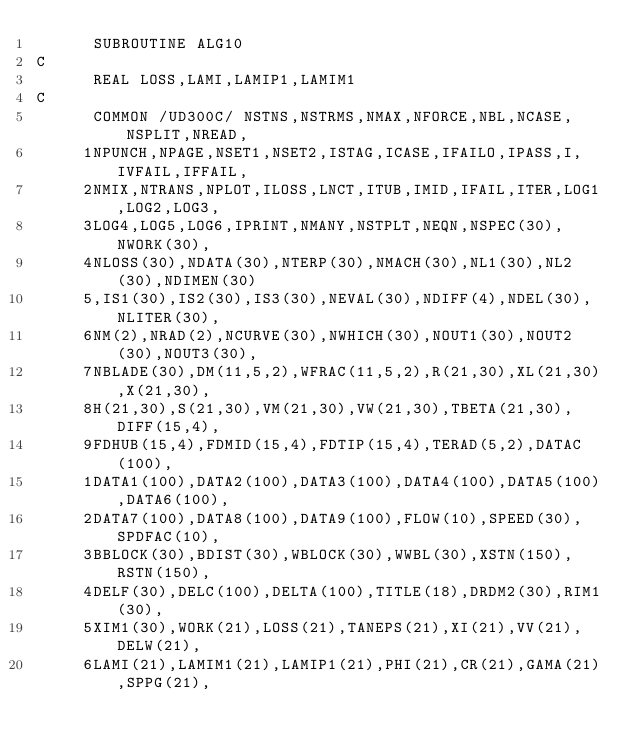<code> <loc_0><loc_0><loc_500><loc_500><_FORTRAN_>      SUBROUTINE ALG10
C
      REAL LOSS,LAMI,LAMIP1,LAMIM1
C
      COMMON /UD300C/ NSTNS,NSTRMS,NMAX,NFORCE,NBL,NCASE,NSPLIT,NREAD,
     1NPUNCH,NPAGE,NSET1,NSET2,ISTAG,ICASE,IFAILO,IPASS,I,IVFAIL,IFFAIL,
     2NMIX,NTRANS,NPLOT,ILOSS,LNCT,ITUB,IMID,IFAIL,ITER,LOG1,LOG2,LOG3,
     3LOG4,LOG5,LOG6,IPRINT,NMANY,NSTPLT,NEQN,NSPEC(30),NWORK(30),
     4NLOSS(30),NDATA(30),NTERP(30),NMACH(30),NL1(30),NL2(30),NDIMEN(30)
     5,IS1(30),IS2(30),IS3(30),NEVAL(30),NDIFF(4),NDEL(30),NLITER(30),
     6NM(2),NRAD(2),NCURVE(30),NWHICH(30),NOUT1(30),NOUT2(30),NOUT3(30),
     7NBLADE(30),DM(11,5,2),WFRAC(11,5,2),R(21,30),XL(21,30),X(21,30),
     8H(21,30),S(21,30),VM(21,30),VW(21,30),TBETA(21,30),DIFF(15,4),
     9FDHUB(15,4),FDMID(15,4),FDTIP(15,4),TERAD(5,2),DATAC(100),
     1DATA1(100),DATA2(100),DATA3(100),DATA4(100),DATA5(100),DATA6(100),
     2DATA7(100),DATA8(100),DATA9(100),FLOW(10),SPEED(30),SPDFAC(10),
     3BBLOCK(30),BDIST(30),WBLOCK(30),WWBL(30),XSTN(150),RSTN(150),
     4DELF(30),DELC(100),DELTA(100),TITLE(18),DRDM2(30),RIM1(30),
     5XIM1(30),WORK(21),LOSS(21),TANEPS(21),XI(21),VV(21),DELW(21),
     6LAMI(21),LAMIM1(21),LAMIP1(21),PHI(21),CR(21),GAMA(21),SPPG(21),</code> 